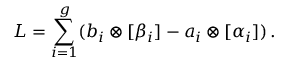<formula> <loc_0><loc_0><loc_500><loc_500>L = \sum _ { i = 1 } ^ { g } ( b _ { i } \otimes [ \beta _ { i } ] - a _ { i } \otimes [ \alpha _ { i } ] ) \, .</formula> 